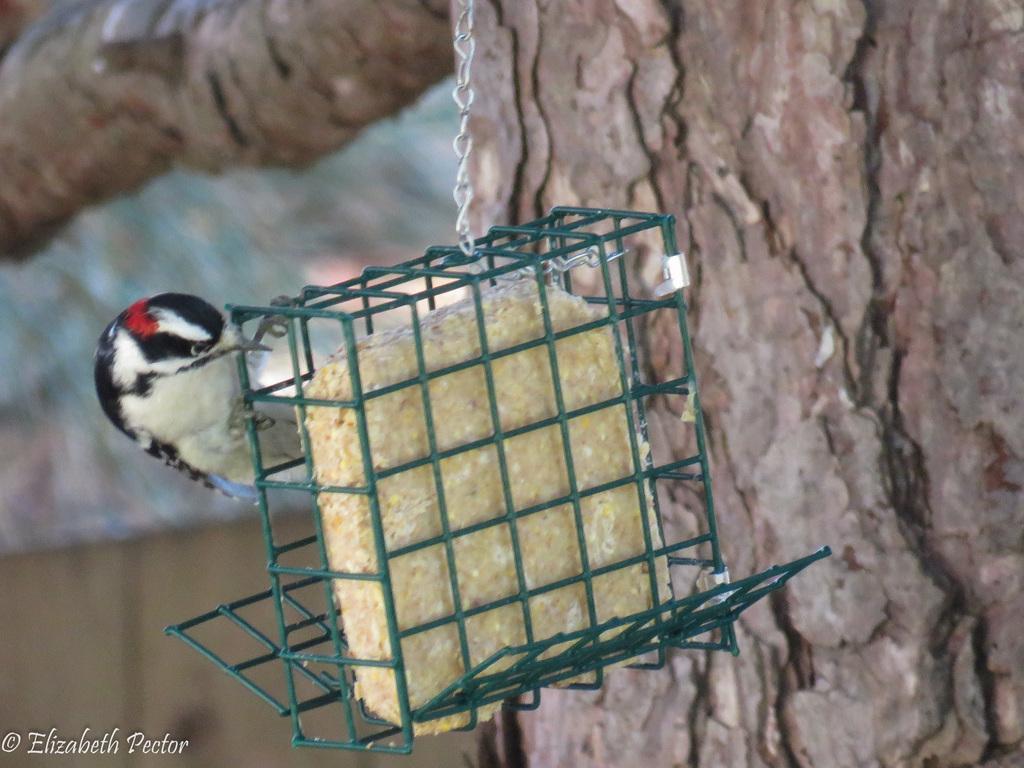Could you give a brief overview of what you see in this image? This is the picture of a bird which is on the cage which is fixed to the tree trunk. 